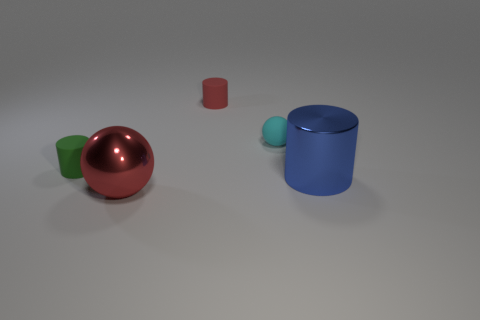Add 3 red spheres. How many objects exist? 8 Subtract all spheres. How many objects are left? 3 Subtract all small blue metallic blocks. Subtract all red matte things. How many objects are left? 4 Add 5 small green rubber cylinders. How many small green rubber cylinders are left? 6 Add 5 green cylinders. How many green cylinders exist? 6 Subtract 0 cyan blocks. How many objects are left? 5 